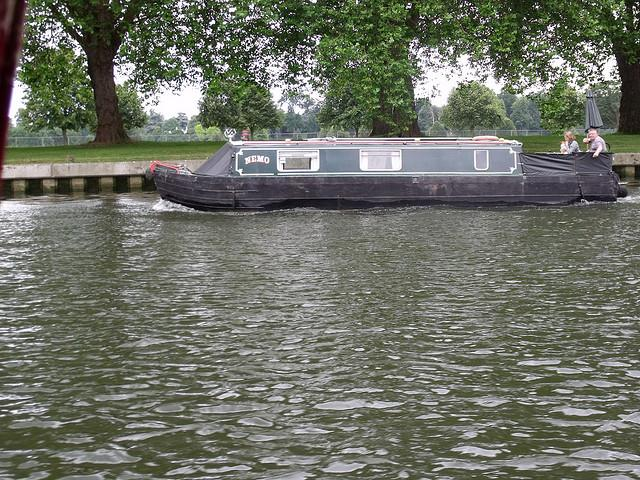What does the word on the boat relate? nemo 